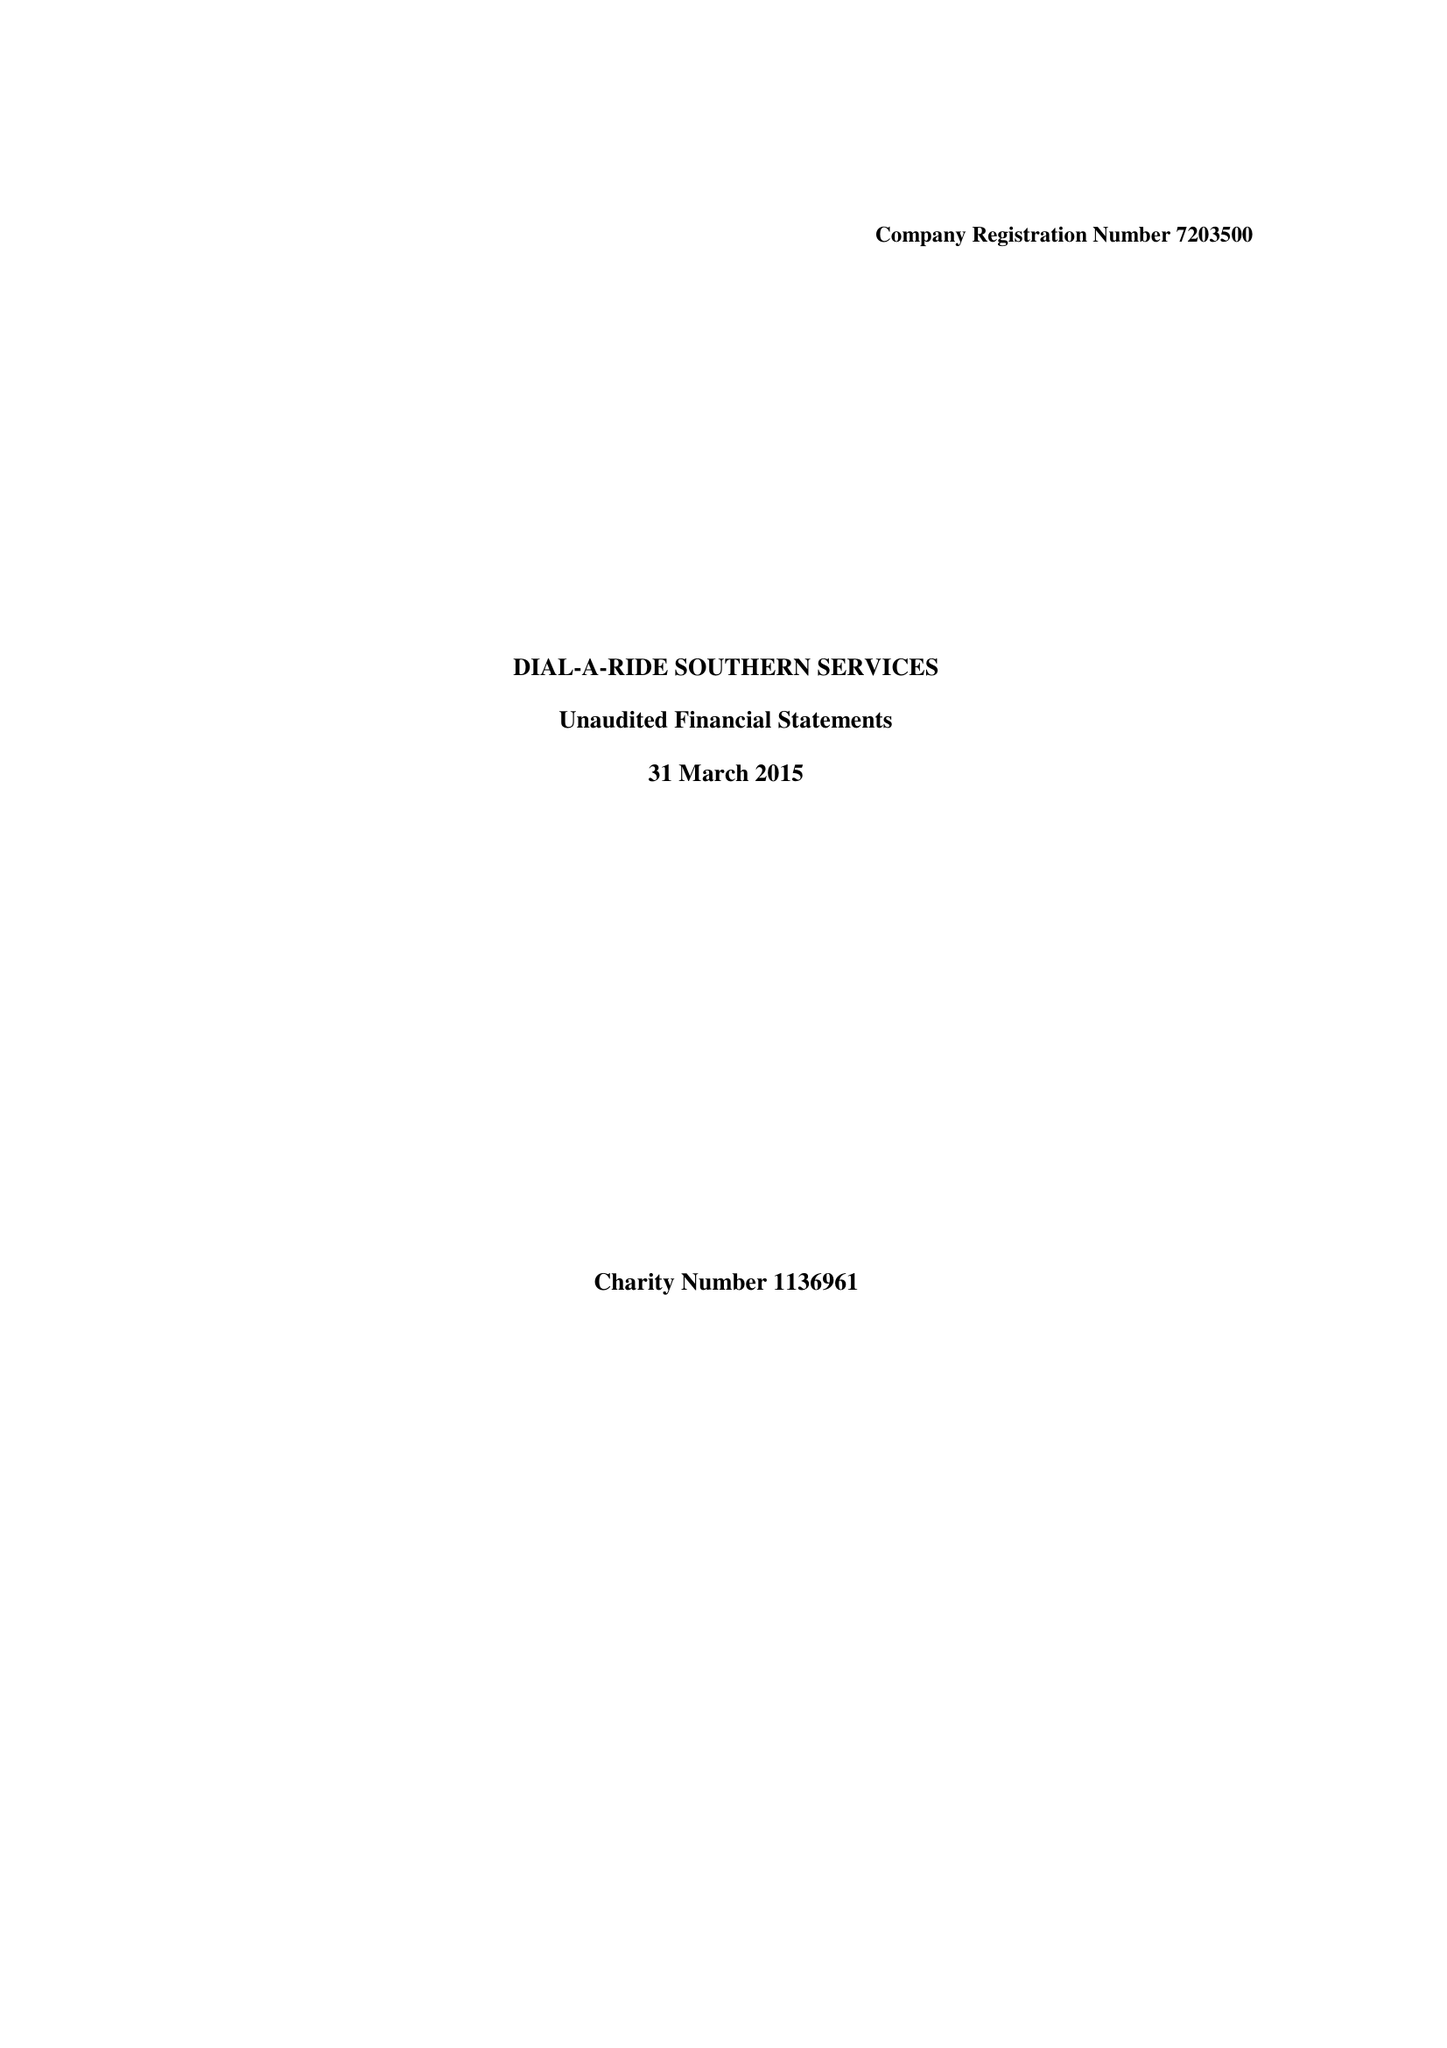What is the value for the charity_number?
Answer the question using a single word or phrase. 1136961 